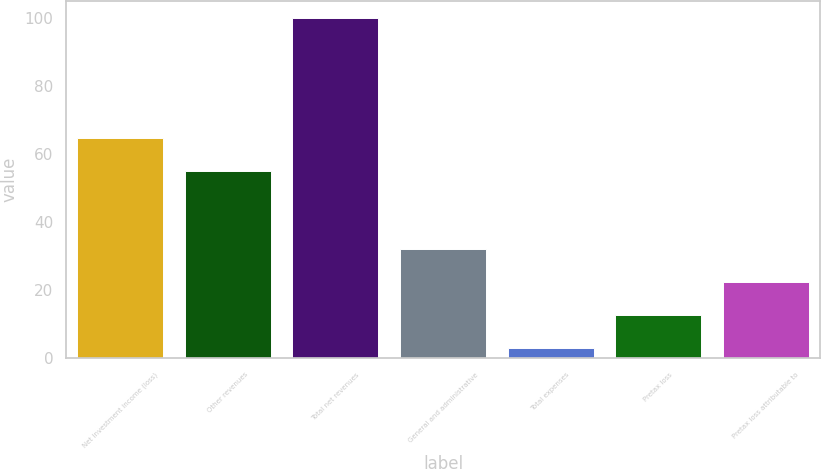Convert chart. <chart><loc_0><loc_0><loc_500><loc_500><bar_chart><fcel>Net investment income (loss)<fcel>Other revenues<fcel>Total net revenues<fcel>General and administrative<fcel>Total expenses<fcel>Pretax loss<fcel>Pretax loss attributable to<nl><fcel>64.7<fcel>55<fcel>100<fcel>32.1<fcel>3<fcel>12.7<fcel>22.4<nl></chart> 